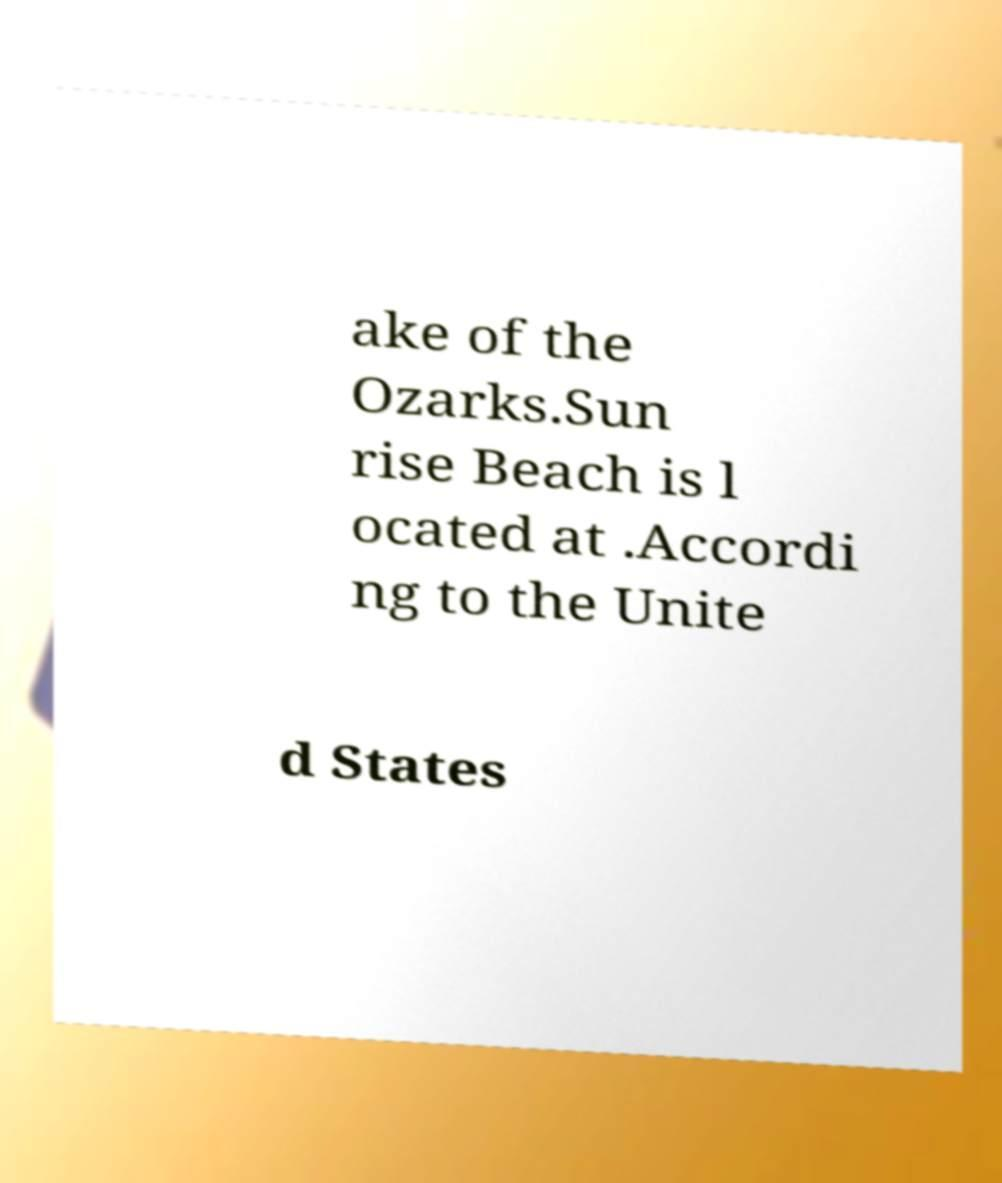I need the written content from this picture converted into text. Can you do that? ake of the Ozarks.Sun rise Beach is l ocated at .Accordi ng to the Unite d States 